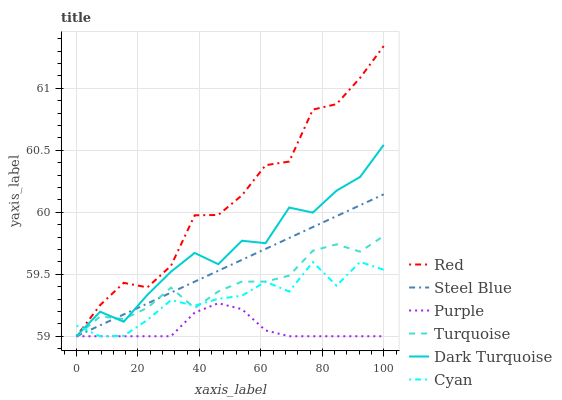Does Purple have the minimum area under the curve?
Answer yes or no. Yes. Does Red have the maximum area under the curve?
Answer yes or no. Yes. Does Dark Turquoise have the minimum area under the curve?
Answer yes or no. No. Does Dark Turquoise have the maximum area under the curve?
Answer yes or no. No. Is Steel Blue the smoothest?
Answer yes or no. Yes. Is Red the roughest?
Answer yes or no. Yes. Is Purple the smoothest?
Answer yes or no. No. Is Purple the roughest?
Answer yes or no. No. Does Red have the highest value?
Answer yes or no. Yes. Does Dark Turquoise have the highest value?
Answer yes or no. No. Does Red intersect Dark Turquoise?
Answer yes or no. Yes. Is Red less than Dark Turquoise?
Answer yes or no. No. Is Red greater than Dark Turquoise?
Answer yes or no. No. 